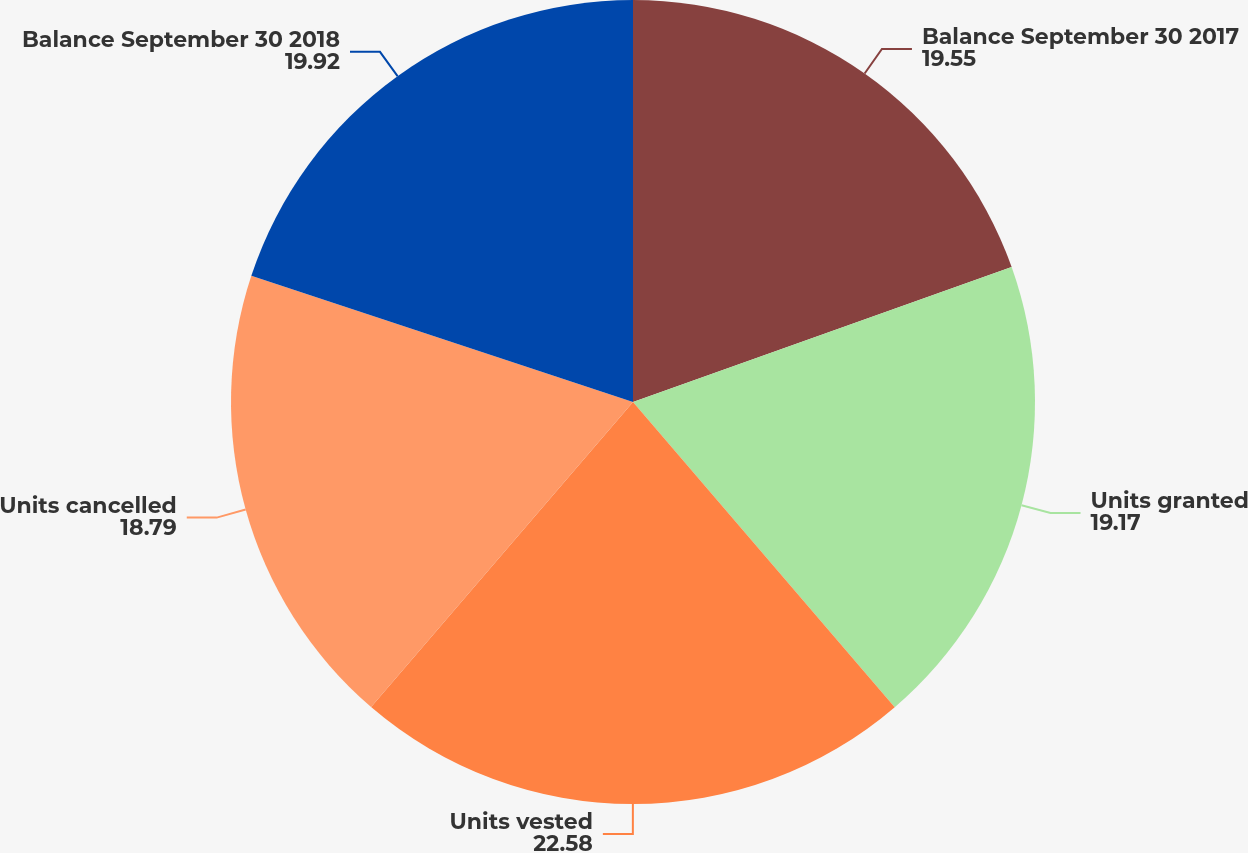<chart> <loc_0><loc_0><loc_500><loc_500><pie_chart><fcel>Balance September 30 2017<fcel>Units granted<fcel>Units vested<fcel>Units cancelled<fcel>Balance September 30 2018<nl><fcel>19.55%<fcel>19.17%<fcel>22.58%<fcel>18.79%<fcel>19.92%<nl></chart> 